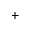<formula> <loc_0><loc_0><loc_500><loc_500>^ { + }</formula> 